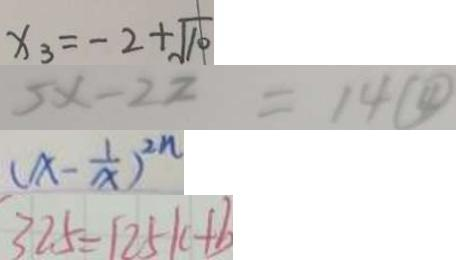Convert formula to latex. <formula><loc_0><loc_0><loc_500><loc_500>x _ { 3 } = - 2 + \sqrt { 1 0 } 
 5 x - 2 2 = 1 4 \textcircled { 4 } 
 ( x - \frac { 1 } { x } ) ^ { 2 n } 
 3 2 . 5 = 1 2 5 k + b</formula> 